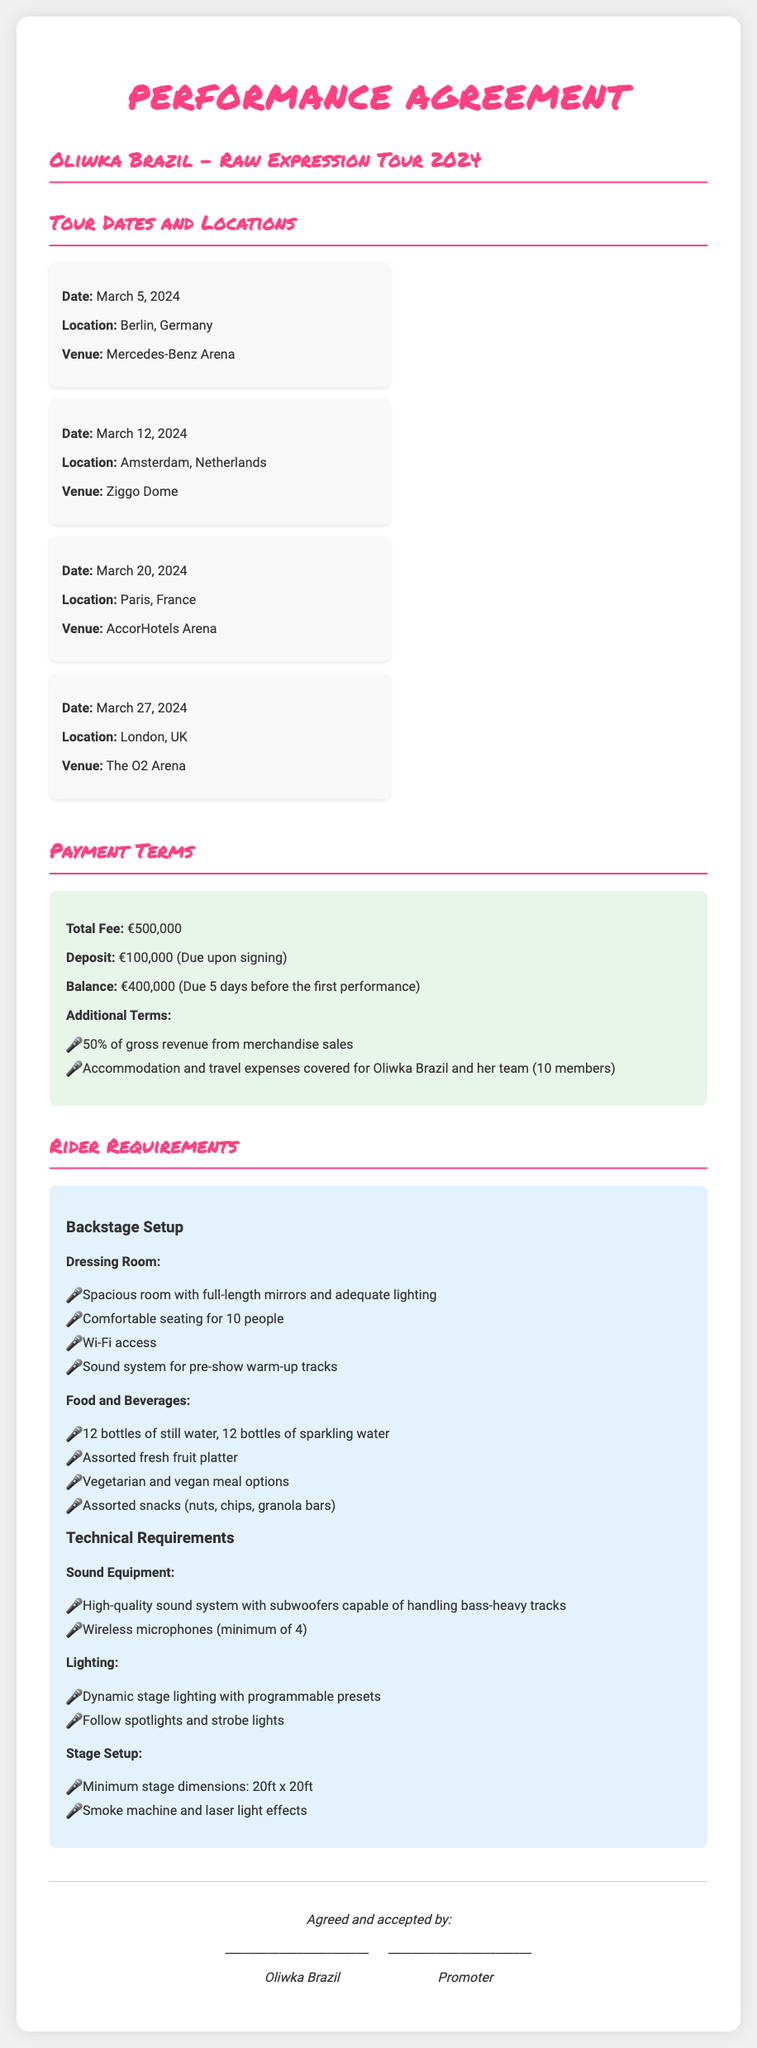What is the date of the first concert? The first concert is scheduled for the date mentioned in the document under the tour dates section, which is March 5, 2024.
Answer: March 5, 2024 Where is the concert on March 20, 2024? The concert on March 20, 2024, takes place in the location specified in the tour dates section, which is Paris, France.
Answer: Paris, France What is the total fee for the tour? The total fee is stated in the payment terms section of the document, which is €500,000.
Answer: €500,000 How many members are covered for accommodation and travel expenses? The number of team members is specified in the payment terms section, which states that 10 members are covered.
Answer: 10 What is required in the dressing room? The dressing room requirements are listed in the rider requirements section, which includes a spacious room with full-length mirrors and adequate lighting.
Answer: Spacious room with full-length mirrors What type of meal options are requested? The meal options requested in the rider requirements under food and beverages include vegetarian and vegan meal options.
Answer: Vegetarian and vegan meal options What is the balance due before the first performance? The balance due is stated in the payment terms section of the document, which is €400,000.
Answer: €400,000 What type of microphones are needed? The document specifies under technical requirements that a minimum of 4 wireless microphones is needed.
Answer: Wireless microphones (minimum of 4) What is the minimum stage dimension? The minimum stage dimensions are mentioned in the rider requirements section, which states 20ft x 20ft.
Answer: 20ft x 20ft 